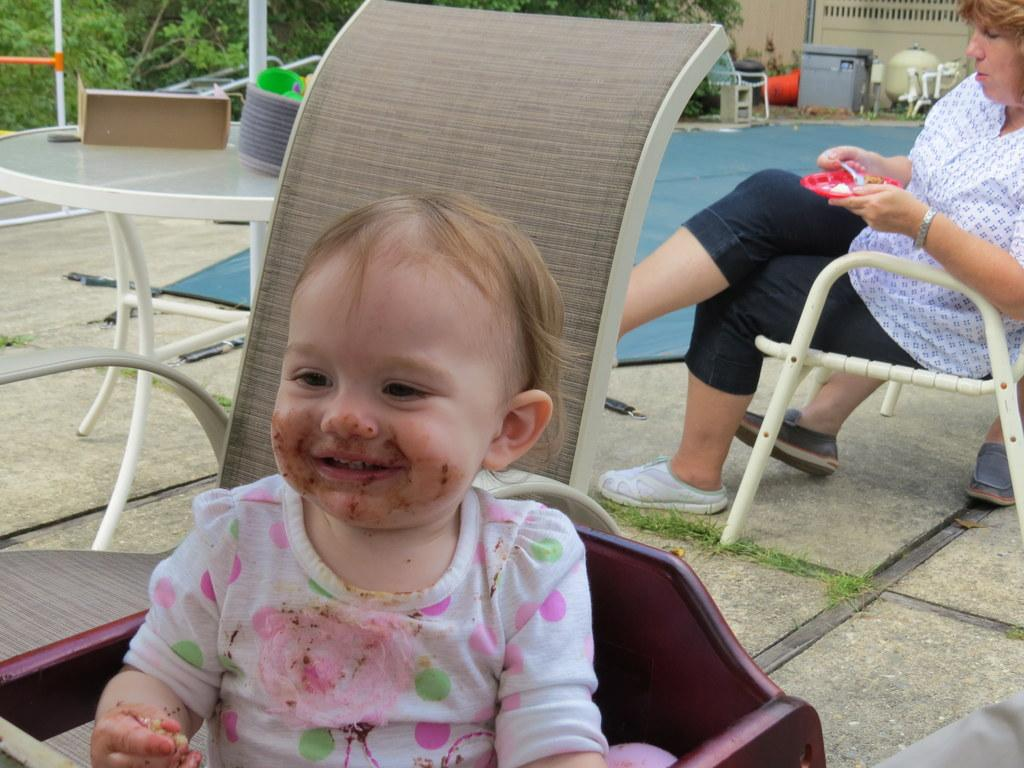Who is present in the image? There is a man, a baby, and a woman in the image. What are the man and the baby doing in the image? Both the man and the baby are seated on a chair. What is the woman holding in the image? The woman is holding a plate in her hand. What is the woman doing with the food on the plate? The woman is taking food from the plate. What can be seen in the background of the image? There are trees visible in the image. What type of wound can be seen on the man's brain in the image? There is no mention of a man's brain or any wound in the image; it only features a man, a baby, and a woman. 